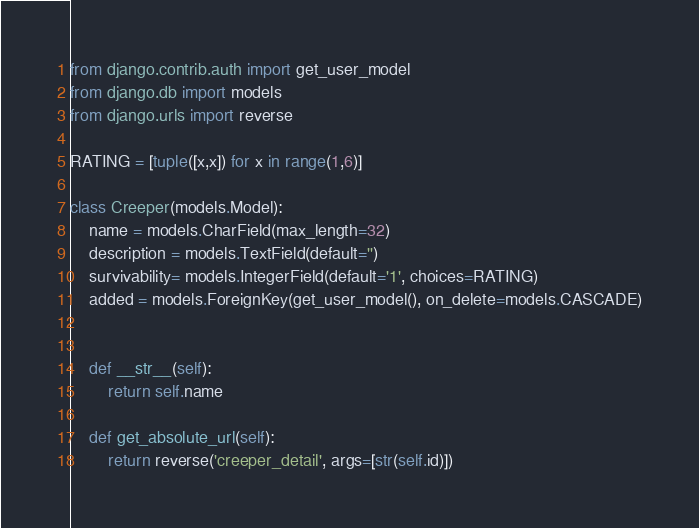<code> <loc_0><loc_0><loc_500><loc_500><_Python_>from django.contrib.auth import get_user_model
from django.db import models
from django.urls import reverse

RATING = [tuple([x,x]) for x in range(1,6)]

class Creeper(models.Model):
    name = models.CharField(max_length=32)
    description = models.TextField(default='')
    survivability= models.IntegerField(default='1', choices=RATING)
    added = models.ForeignKey(get_user_model(), on_delete=models.CASCADE)


    def __str__(self):
        return self.name

    def get_absolute_url(self):
        return reverse('creeper_detail', args=[str(self.id)])
</code> 